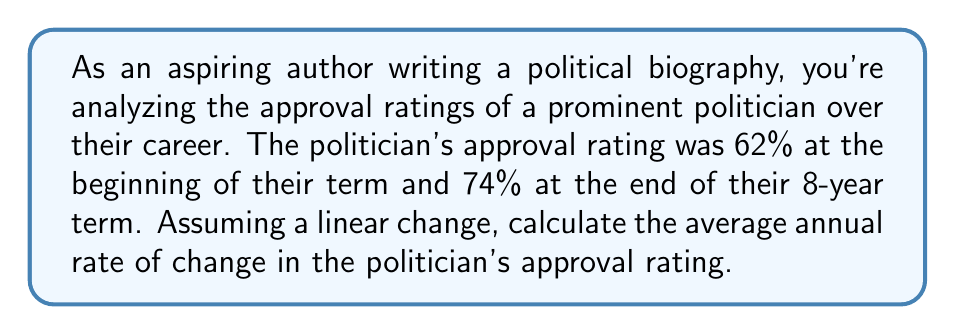Could you help me with this problem? To solve this problem, we need to use the concept of rate of change. The rate of change is the difference in a quantity over a period of time. In this case, we're looking for the average annual rate of change in approval rating.

Let's break it down step by step:

1. Initial approval rating: 62%
2. Final approval rating: 74%
3. Time period: 8 years

The total change in approval rating is:
$$ \text{Total change} = \text{Final rating} - \text{Initial rating} = 74\% - 62\% = 12\% $$

To find the average annual rate of change, we divide the total change by the number of years:

$$ \text{Average annual rate of change} = \frac{\text{Total change}}{\text{Number of years}} $$

$$ = \frac{12\%}{8 \text{ years}} $$

$$ = 1.5\% \text{ per year} $$

This means that, on average, the politician's approval rating increased by 1.5 percentage points each year over their 8-year term.
Answer: The average annual rate of change in the politician's approval rating is 1.5% per year. 